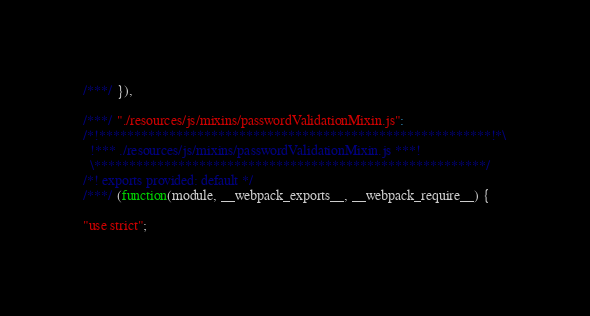<code> <loc_0><loc_0><loc_500><loc_500><_JavaScript_>
/***/ }),

/***/ "./resources/js/mixins/passwordValidationMixin.js":
/*!********************************************************!*\
  !*** ./resources/js/mixins/passwordValidationMixin.js ***!
  \********************************************************/
/*! exports provided: default */
/***/ (function(module, __webpack_exports__, __webpack_require__) {

"use strict";</code> 